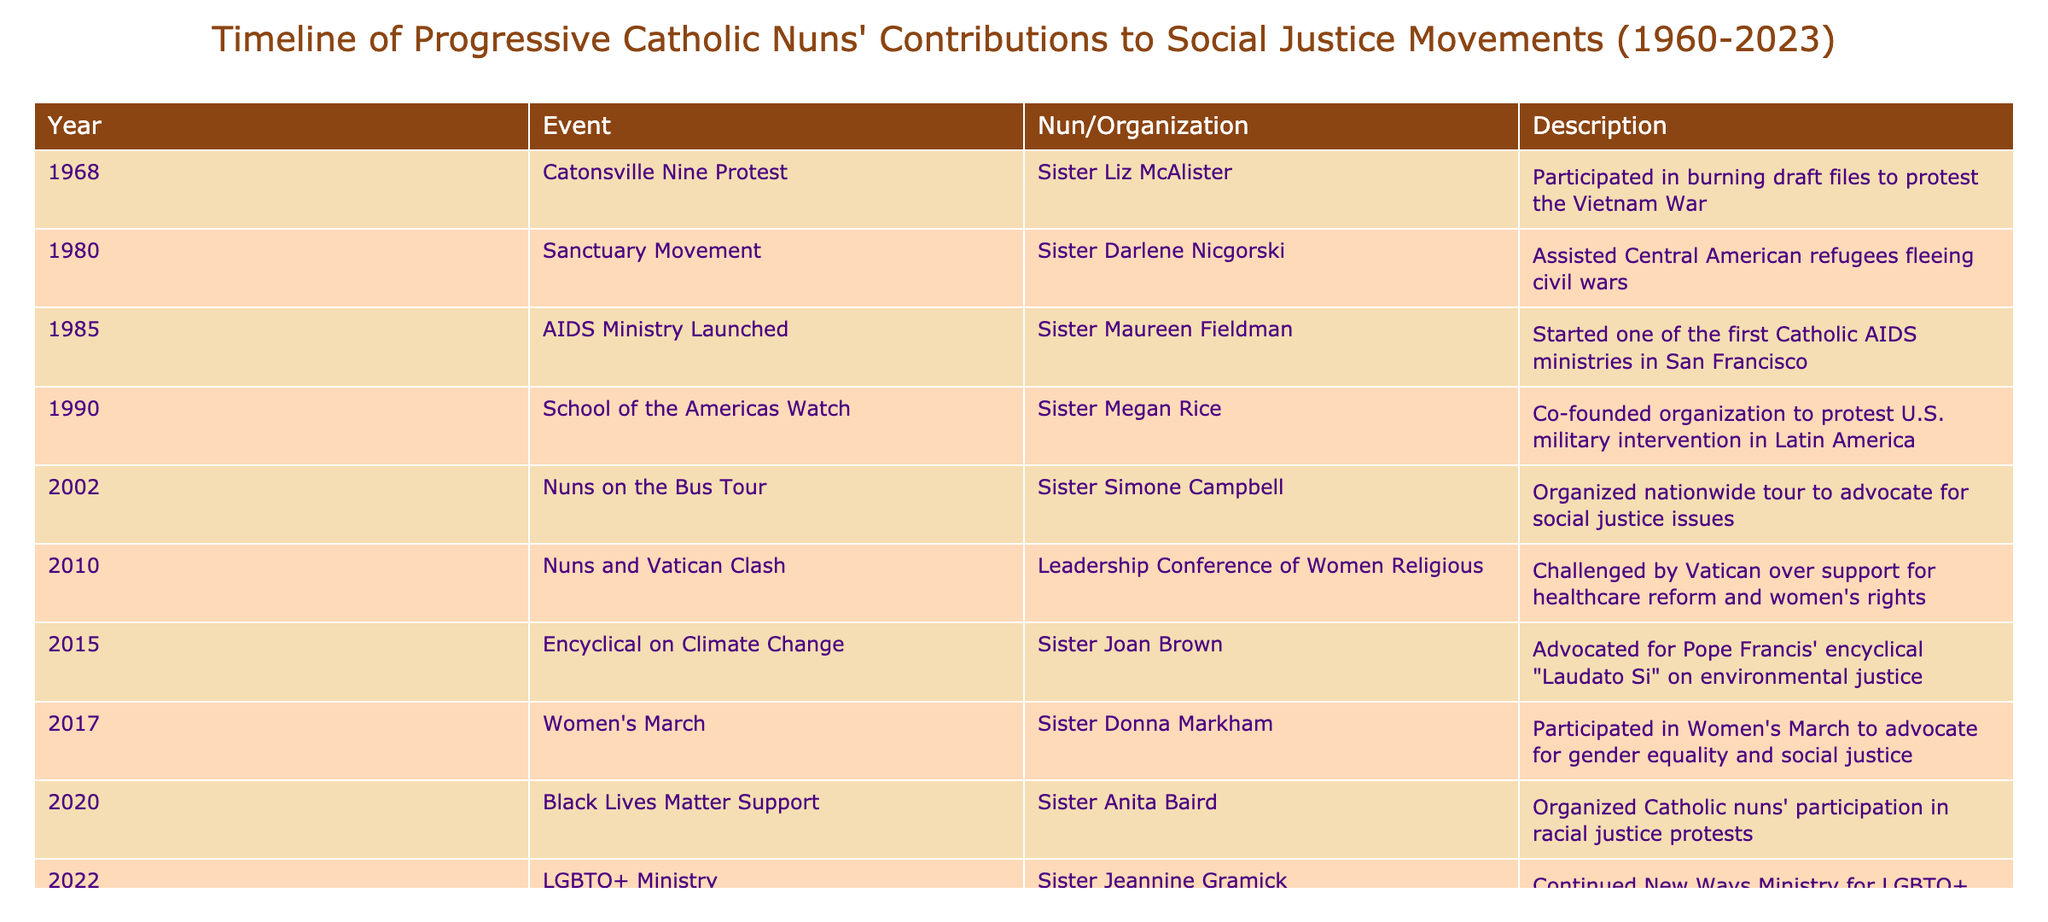What year did Sister Liz McAlister participate in the Catonsville Nine protest? According to the table, Sister Liz McAlister participated in the Catonsville Nine protest in the year 1968.
Answer: 1968 How many events occurred in the 2000s? Observing the table, the events listed from the 2000s are: Nuns on the Bus Tour (2002) and Nuns and Vatican Clash (2010), which accounts for 2 events in that decade.
Answer: 2 Was there any contribution related to LGBTQ+ issues before 2020? The table shows that Sister Jeannine Gramick's work for LGBTQ+ Catholics took place in 2022, which means there was no documented contribution related to LGBTQ+ issues prior to 2020.
Answer: No Who co-founded the School of the Americas Watch? The table indicates that Sister Megan Rice co-founded the School of the Americas Watch in 1990.
Answer: Sister Megan Rice What was the first event listed that directly mentioned climate justice? The first event that directly mentioned climate justice is the "Encyclical on Climate Change" led by Sister Joan Brown in 2015, as noted in the table.
Answer: Encyclical on Climate Change How many years span between Sister Darlene Nicgorski's involvement in the Sanctuary Movement and Sister Anita Baird's support for Black Lives Matter? Sister Darlene Nicgorski's involvement was in 1980, and Sister Anita Baird's support was in 2020. Thus, the gap is 2020 - 1980 = 40 years.
Answer: 40 years Did all events listed concern social justice? Looking at the table, every event does focus on social justice aspects, covering themes such as racial equality, climate change, and healthcare reform.
Answer: Yes Which nun was involved in the Women's March in 2017? Sister Donna Markham participated in the Women's March, as indicated in the table for the year 2017.
Answer: Sister Donna Markham 